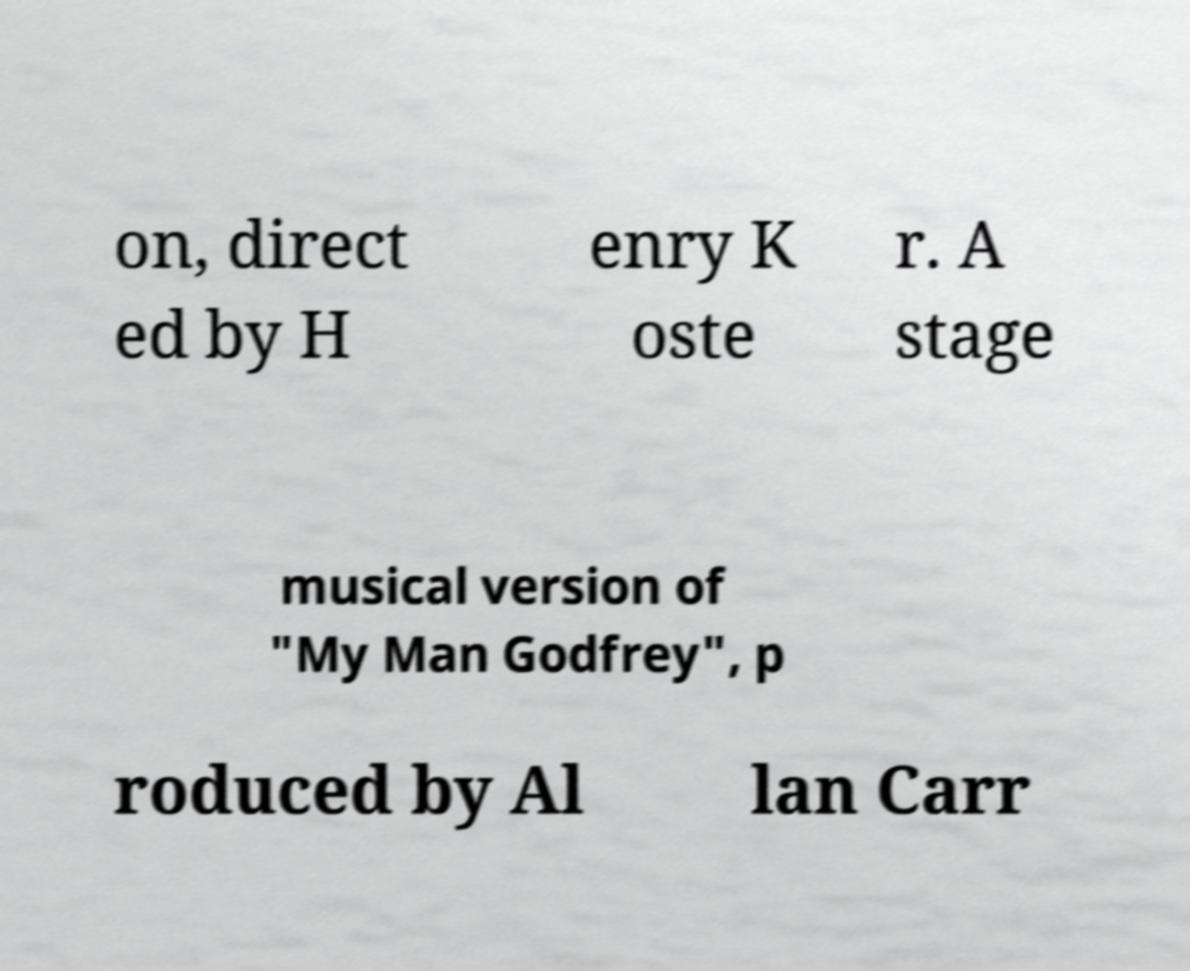Could you assist in decoding the text presented in this image and type it out clearly? on, direct ed by H enry K oste r. A stage musical version of "My Man Godfrey", p roduced by Al lan Carr 